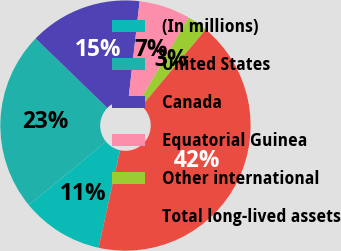Convert chart. <chart><loc_0><loc_0><loc_500><loc_500><pie_chart><fcel>(In millions)<fcel>United States<fcel>Canada<fcel>Equatorial Guinea<fcel>Other international<fcel>Total long-lived assets<nl><fcel>10.59%<fcel>23.21%<fcel>14.56%<fcel>6.62%<fcel>2.65%<fcel>42.37%<nl></chart> 